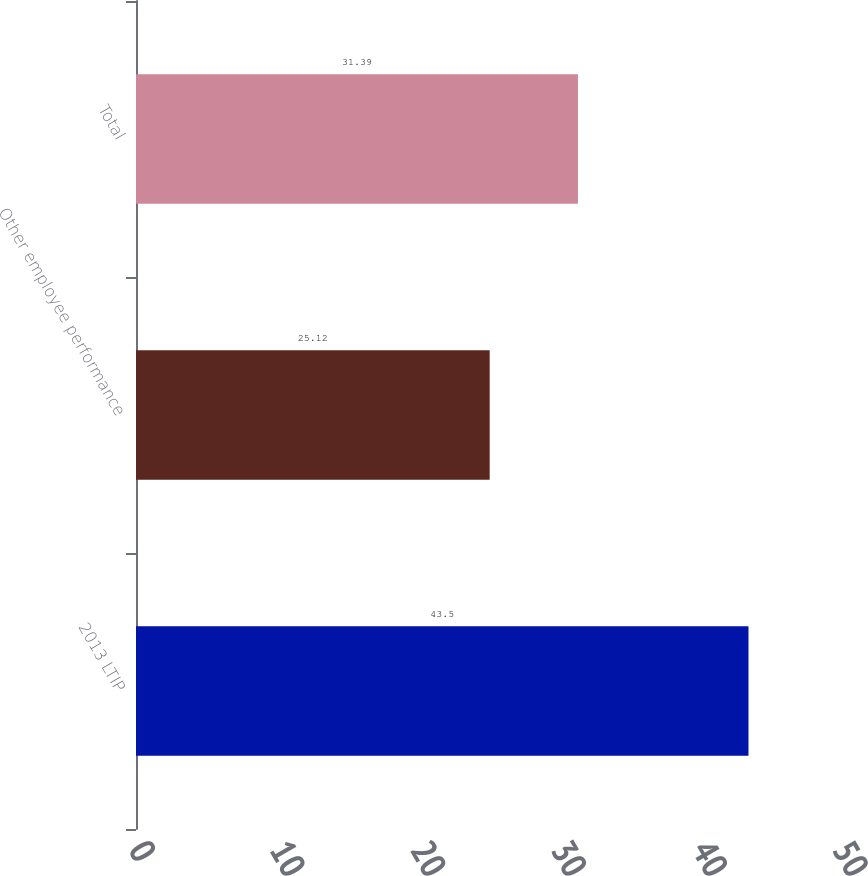Convert chart. <chart><loc_0><loc_0><loc_500><loc_500><bar_chart><fcel>2013 LTIP<fcel>Other employee performance<fcel>Total<nl><fcel>43.5<fcel>25.12<fcel>31.39<nl></chart> 